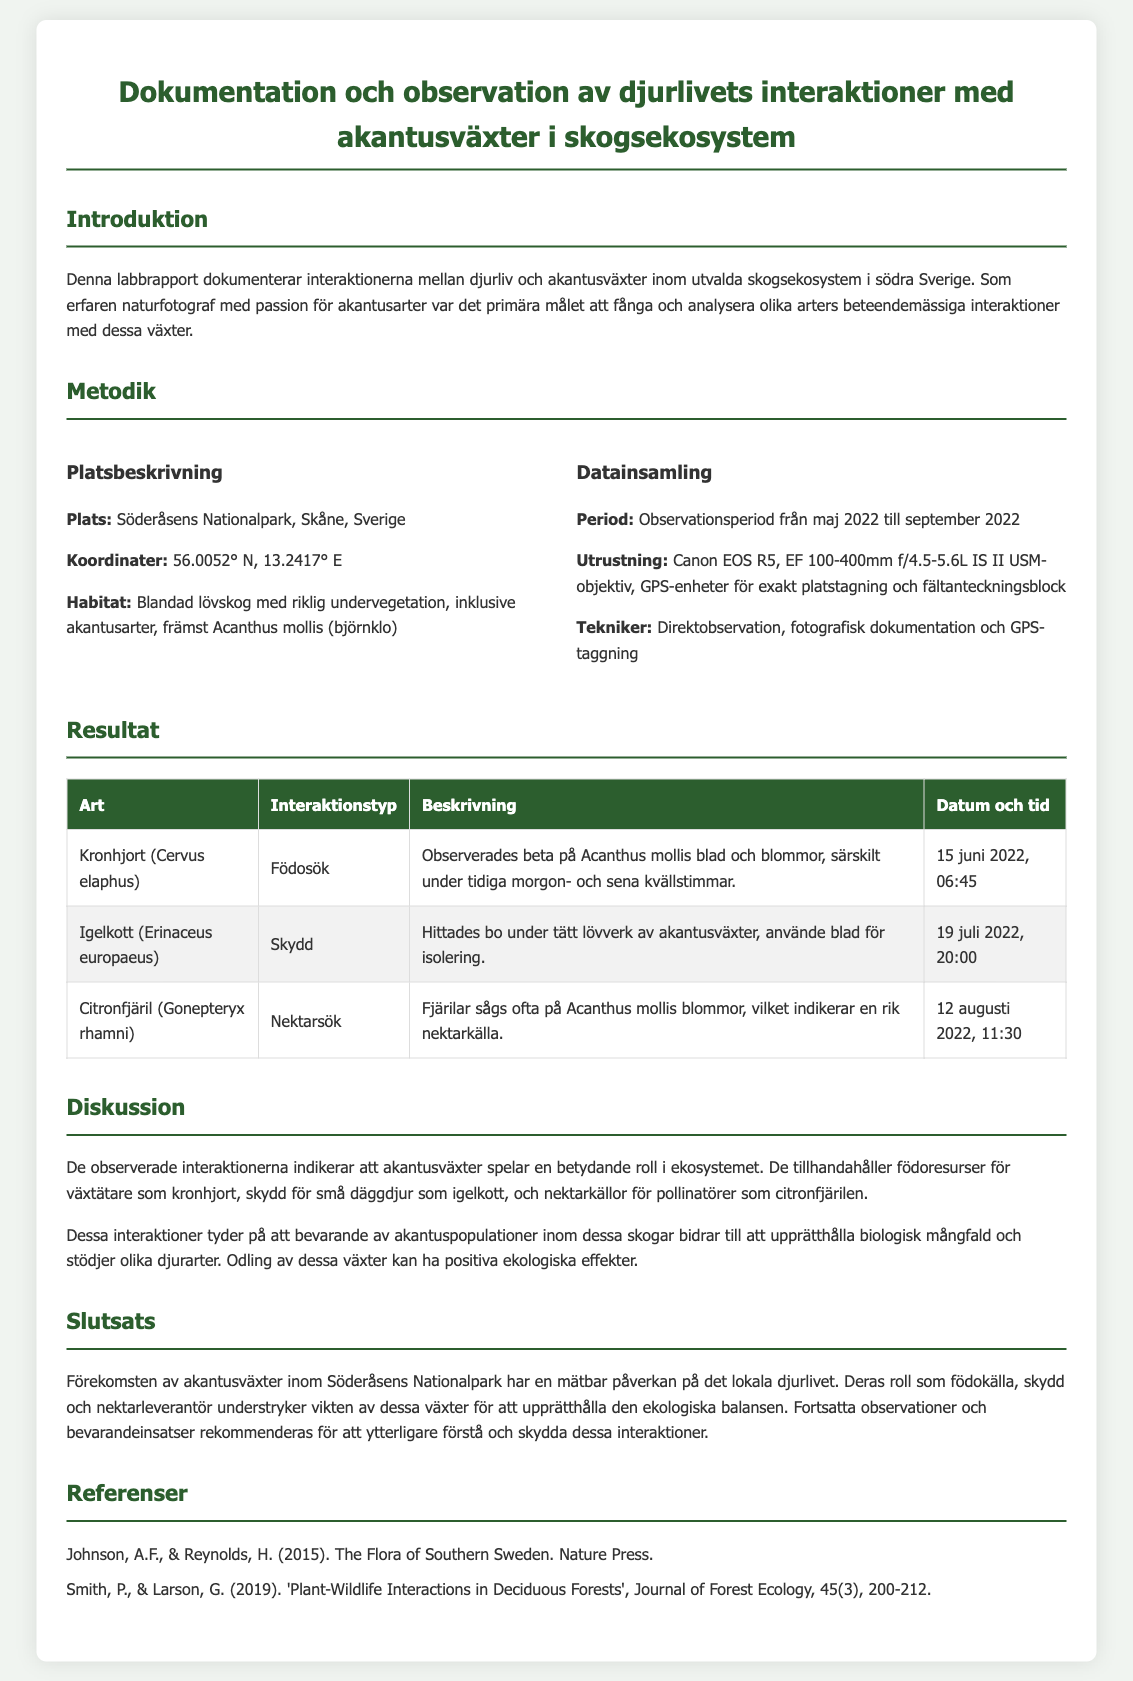vad är platsen för studien? Platsen för studien är angiven i avsnittet om platsbeskrivning, vilket visar att det är Söderåsens Nationalpark i Skåne, Sverige.
Answer: Söderåsens Nationalpark, Skåne, Sverige vilken art observerades som betade på akantusväxter? I resultatavsnittet nämns att kronhjort (Cervus elaphus) observerades betande på Acanthus mollis.
Answer: Kronhjort (Cervus elaphus) vilket datum observerades igelkottens skydd? Datumet för igelkottens observation finns i resultatavsnittet och är specificerat som den 19 juli 2022.
Answer: 19 juli 2022 vad var syftet med studien? Syftet med studien beskrivs i introduktionen där det anges att målet var att fånga och analysera djurens beteendemässiga interaktioner med akantusväxter.
Answer: Fånga och analysera djurens beteendemässiga interaktioner vilken teknik användes för datainsamling? Teknikerna för datainsamling är listade under avsnittet om datainsamling och nämner direktobservation, fotografisk dokumentation och GPS-taggning.
Answer: Direktobservation, fotografisk dokumentation och GPS-taggning hur påverkar akantusväxter det lokala djurlivet? Detta beskrivs i diskussionsavsnittet som att akantusväxter spelar en betydande roll i ekosystemet, så det påverkar födoresurser och skydd för djuren.
Answer: Spelar en betydande roll i ekosystemet vilken typ av fjäril observerades på akantusväxter? Typen av fjäril som observerades är nämnd i resultatavsnittet, specifikt som citronfjäril (Gonepteryx rhamni).
Answer: Citronfjäril (Gonepteryx rhamni) vad är en rekommendation som ges i slutsatsen? I slutsatsen rekommenderas fortsatt övervakning och bevarandeinsatser för att skydda interaktioner mellan djurlivet och akantusväxter.
Answer: Fortsatta observationer och bevarandeinsatser vad är habitatet för studien? Habitatet som beskrivs i platsbeskrivningen är en blandad lövskog med riklig undervegetation, vilket inkluderar akantusarter.
Answer: Blandad lövskog med riklig undervegetation 